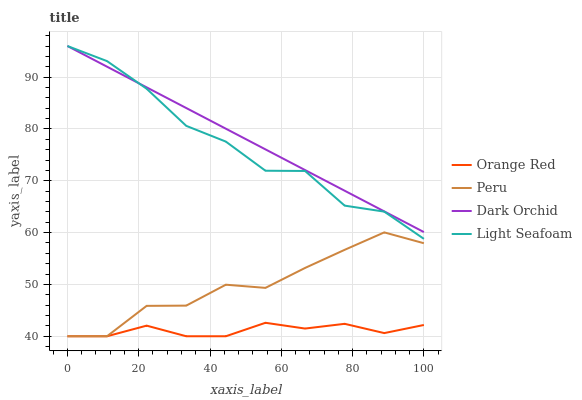Does Orange Red have the minimum area under the curve?
Answer yes or no. Yes. Does Dark Orchid have the maximum area under the curve?
Answer yes or no. Yes. Does Light Seafoam have the minimum area under the curve?
Answer yes or no. No. Does Light Seafoam have the maximum area under the curve?
Answer yes or no. No. Is Dark Orchid the smoothest?
Answer yes or no. Yes. Is Light Seafoam the roughest?
Answer yes or no. Yes. Is Orange Red the smoothest?
Answer yes or no. No. Is Orange Red the roughest?
Answer yes or no. No. Does Light Seafoam have the lowest value?
Answer yes or no. No. Does Light Seafoam have the highest value?
Answer yes or no. Yes. Does Orange Red have the highest value?
Answer yes or no. No. Is Peru less than Light Seafoam?
Answer yes or no. Yes. Is Light Seafoam greater than Peru?
Answer yes or no. Yes. Does Dark Orchid intersect Light Seafoam?
Answer yes or no. Yes. Is Dark Orchid less than Light Seafoam?
Answer yes or no. No. Is Dark Orchid greater than Light Seafoam?
Answer yes or no. No. Does Peru intersect Light Seafoam?
Answer yes or no. No. 